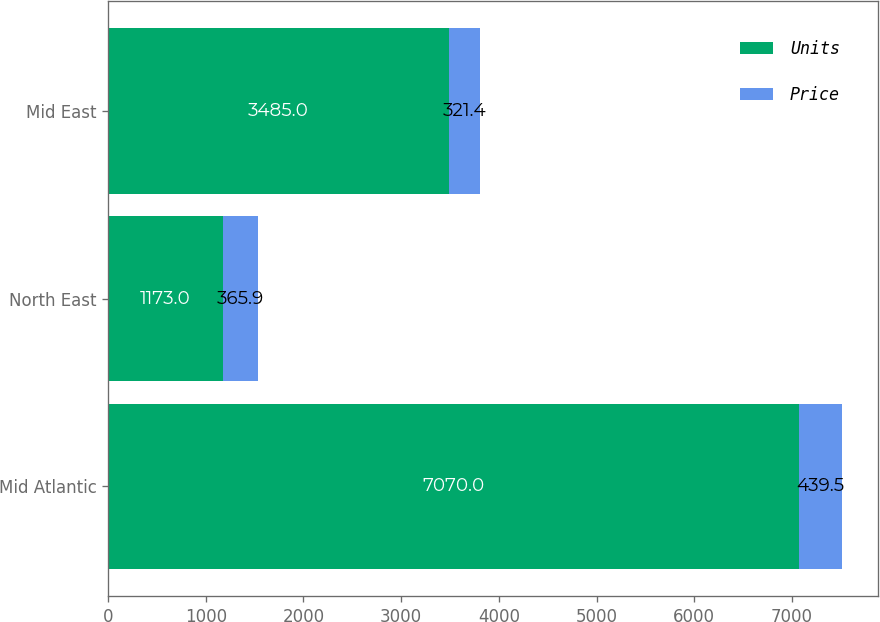Convert chart. <chart><loc_0><loc_0><loc_500><loc_500><stacked_bar_chart><ecel><fcel>Mid Atlantic<fcel>North East<fcel>Mid East<nl><fcel>Units<fcel>7070<fcel>1173<fcel>3485<nl><fcel>Price<fcel>439.5<fcel>365.9<fcel>321.4<nl></chart> 